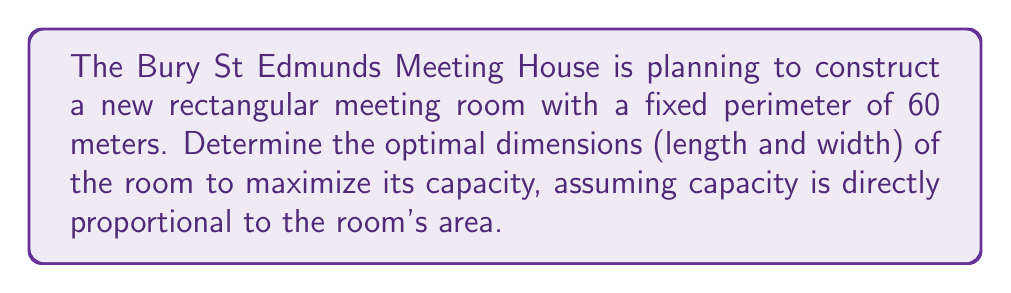Can you solve this math problem? Let's approach this step-by-step:

1) Let $l$ be the length and $w$ be the width of the room.

2) Given that the perimeter is fixed at 60 meters:
   $$2l + 2w = 60$$
   $$l + w = 30$$
   $$w = 30 - l$$

3) The area $A$ of the room is given by:
   $$A = lw = l(30-l) = 30l - l^2$$

4) To maximize the area, we need to find the value of $l$ where the derivative of $A$ with respect to $l$ is zero:

   $$\frac{dA}{dl} = 30 - 2l$$

5) Set this equal to zero and solve:
   $$30 - 2l = 0$$
   $$-2l = -30$$
   $$l = 15$$

6) The second derivative is negative ($-2$), confirming this is a maximum.

7) If $l = 15$, then $w = 30 - 15 = 15$

8) Therefore, the optimal dimensions are 15 meters by 15 meters.

9) We can verify that this indeed gives the maximum area:
   $$A = 15 * 15 = 225 \text{ square meters}$$

This is larger than, for example, 14 * 16 = 224 or 16 * 14 = 224.
Answer: 15 meters by 15 meters 